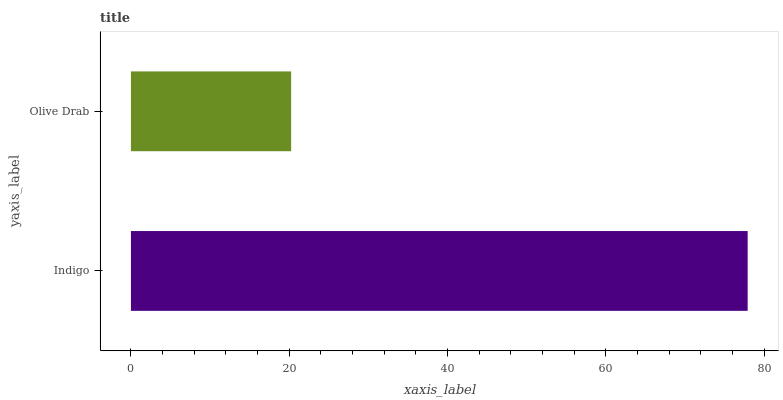Is Olive Drab the minimum?
Answer yes or no. Yes. Is Indigo the maximum?
Answer yes or no. Yes. Is Olive Drab the maximum?
Answer yes or no. No. Is Indigo greater than Olive Drab?
Answer yes or no. Yes. Is Olive Drab less than Indigo?
Answer yes or no. Yes. Is Olive Drab greater than Indigo?
Answer yes or no. No. Is Indigo less than Olive Drab?
Answer yes or no. No. Is Indigo the high median?
Answer yes or no. Yes. Is Olive Drab the low median?
Answer yes or no. Yes. Is Olive Drab the high median?
Answer yes or no. No. Is Indigo the low median?
Answer yes or no. No. 